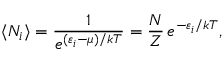<formula> <loc_0><loc_0><loc_500><loc_500>\langle N _ { i } \rangle = { \frac { 1 } { e ^ { ( \varepsilon _ { i } - \mu ) / k T } } } = { \frac { N } { Z } } \, e ^ { - \varepsilon _ { i } / k T } ,</formula> 